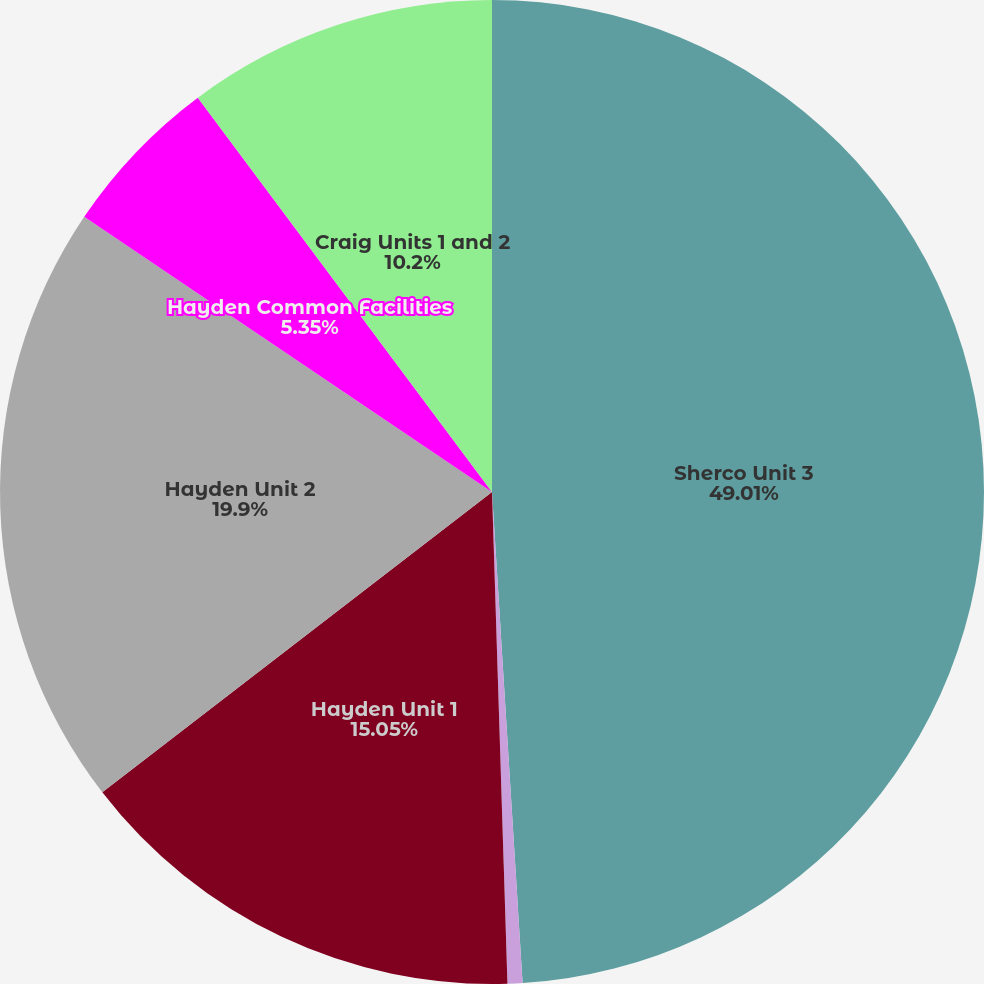<chart> <loc_0><loc_0><loc_500><loc_500><pie_chart><fcel>Sherco Unit 3<fcel>Sherco Common Facilities Units<fcel>Hayden Unit 1<fcel>Hayden Unit 2<fcel>Hayden Common Facilities<fcel>Craig Units 1 and 2<nl><fcel>49.01%<fcel>0.49%<fcel>15.05%<fcel>19.9%<fcel>5.35%<fcel>10.2%<nl></chart> 